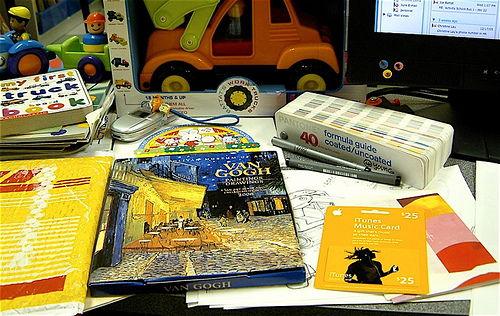<image>
Is there a book under the truck? No. The book is not positioned under the truck. The vertical relationship between these objects is different. 